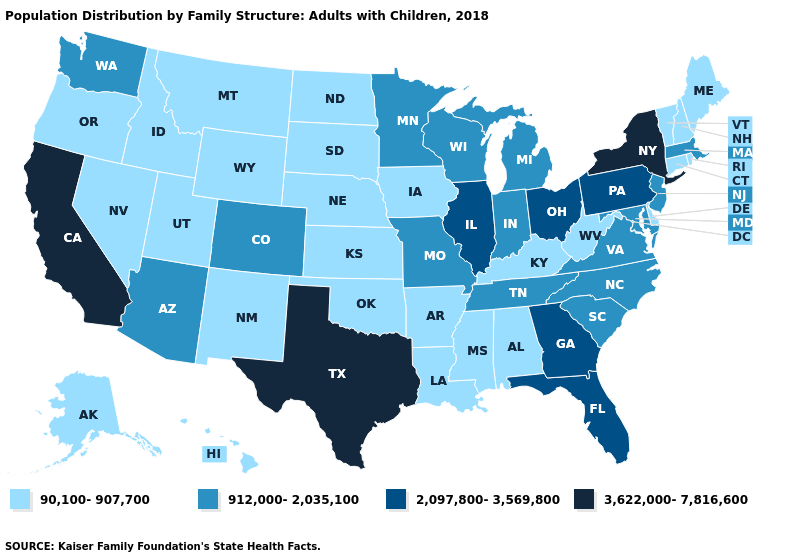Among the states that border Arkansas , which have the lowest value?
Concise answer only. Louisiana, Mississippi, Oklahoma. Name the states that have a value in the range 912,000-2,035,100?
Short answer required. Arizona, Colorado, Indiana, Maryland, Massachusetts, Michigan, Minnesota, Missouri, New Jersey, North Carolina, South Carolina, Tennessee, Virginia, Washington, Wisconsin. What is the value of Florida?
Write a very short answer. 2,097,800-3,569,800. Does Iowa have the lowest value in the USA?
Write a very short answer. Yes. How many symbols are there in the legend?
Write a very short answer. 4. Name the states that have a value in the range 912,000-2,035,100?
Concise answer only. Arizona, Colorado, Indiana, Maryland, Massachusetts, Michigan, Minnesota, Missouri, New Jersey, North Carolina, South Carolina, Tennessee, Virginia, Washington, Wisconsin. Does Oregon have the same value as Washington?
Answer briefly. No. What is the value of Nevada?
Short answer required. 90,100-907,700. Name the states that have a value in the range 912,000-2,035,100?
Short answer required. Arizona, Colorado, Indiana, Maryland, Massachusetts, Michigan, Minnesota, Missouri, New Jersey, North Carolina, South Carolina, Tennessee, Virginia, Washington, Wisconsin. Does Tennessee have a lower value than Vermont?
Quick response, please. No. Name the states that have a value in the range 90,100-907,700?
Be succinct. Alabama, Alaska, Arkansas, Connecticut, Delaware, Hawaii, Idaho, Iowa, Kansas, Kentucky, Louisiana, Maine, Mississippi, Montana, Nebraska, Nevada, New Hampshire, New Mexico, North Dakota, Oklahoma, Oregon, Rhode Island, South Dakota, Utah, Vermont, West Virginia, Wyoming. Does New Hampshire have the highest value in the Northeast?
Quick response, please. No. Does Alaska have the lowest value in the USA?
Keep it brief. Yes. Does the map have missing data?
Write a very short answer. No. 